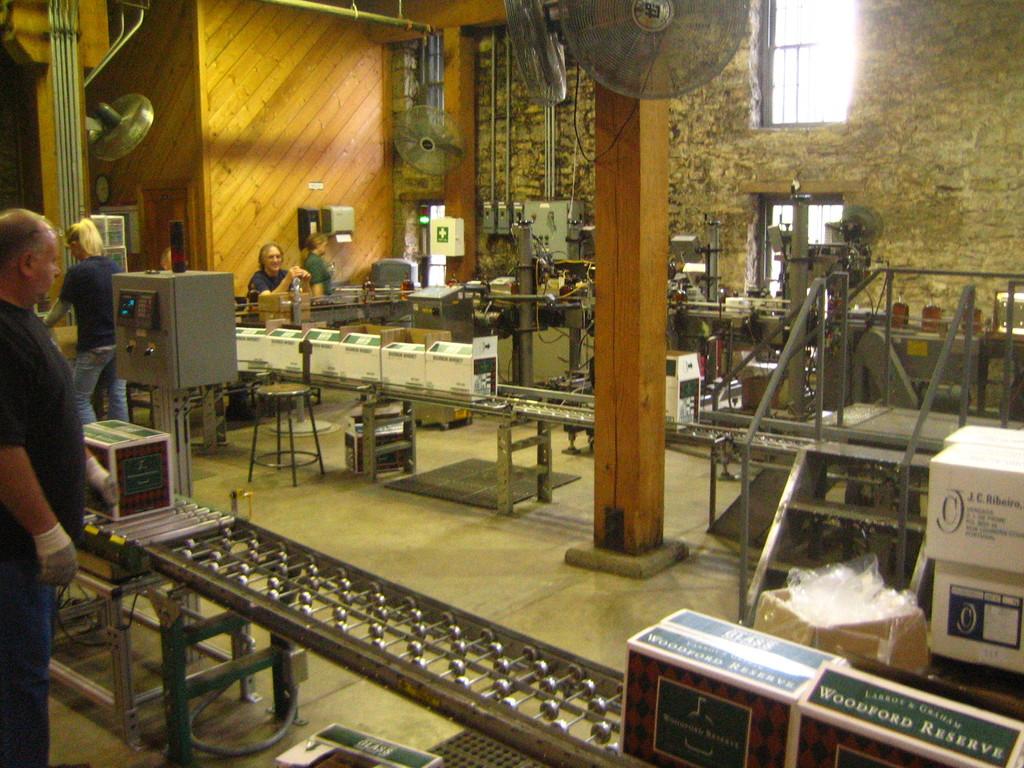What does the box to the bottom right say?
Offer a terse response. Woodford reserve. 